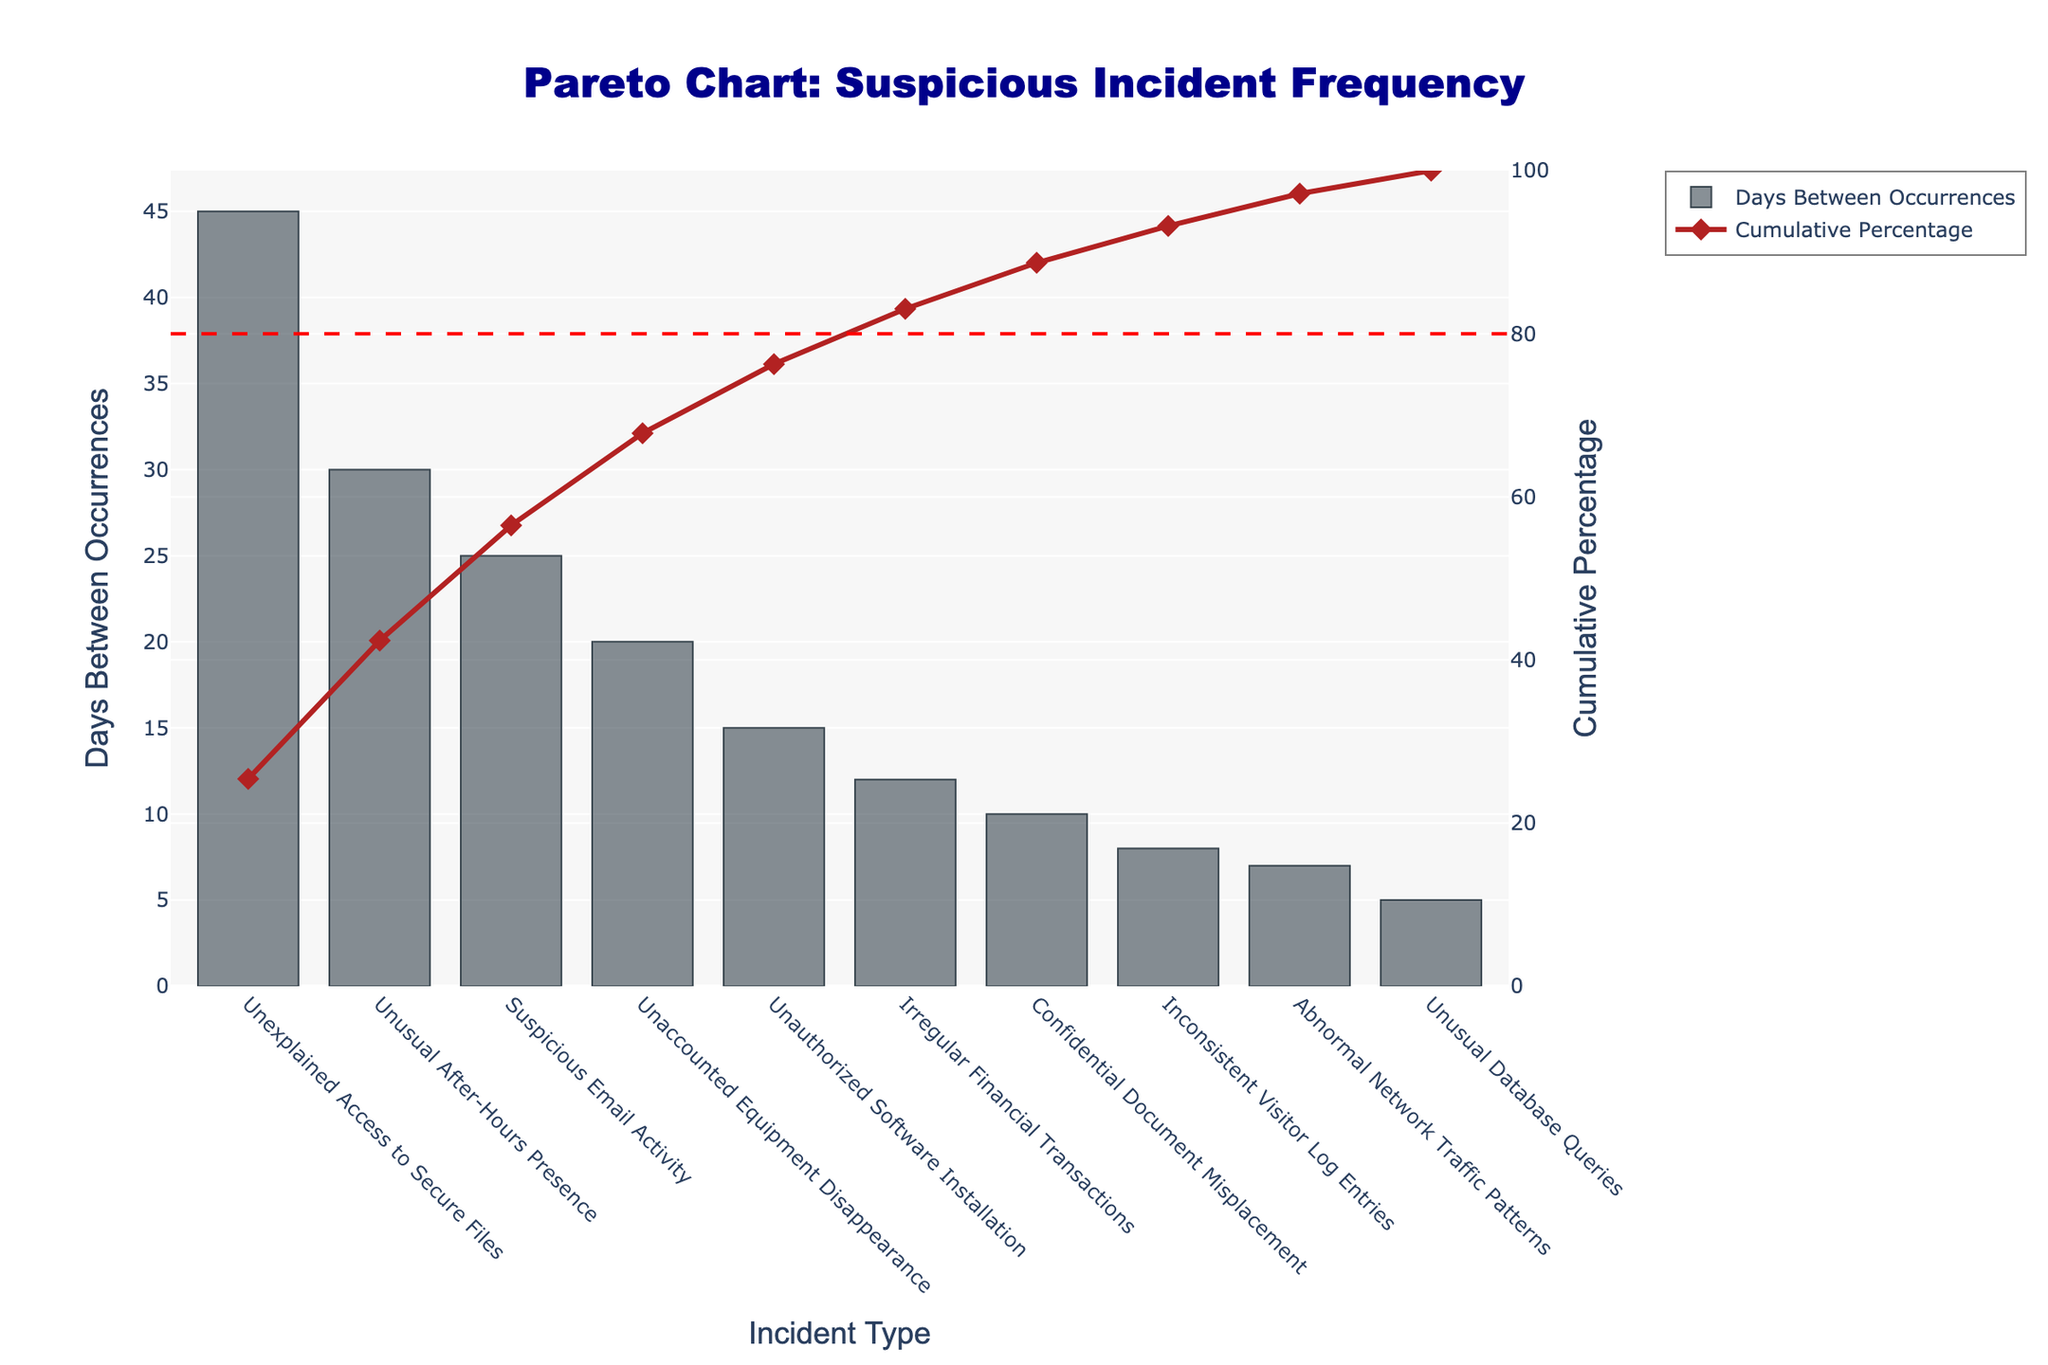What's the title of the chart? The title of the chart is prominently displayed at the top. From the given decorations and position, we can see that it reads "Pareto Chart: Suspicious Incident Frequency."
Answer: Pareto Chart: Suspicious Incident Frequency How many incident types are there in the chart? The chart displays the incident types horizontally along the x-axis. Counting each unique label, we find there are a total of 10 different incident types.
Answer: 10 Which incident type has the longest interval between occurrences? By observing the height of the bars, the "Unexplained Access to Secure Files" bar is the tallest, indicating it has the longest interval between occurrences.
Answer: Unexplained Access to Secure Files What is the cumulative percentage after "Suspicious Email Activity"? We identify the position of "Suspicious Email Activity" on the x-axis and follow the plot from the red line in the right y-axis (Cumulative Percentage). Looking at the point where it aligns, we see the cumulative percentage value.
Answer: Around 53% What is the total interval time between occurrences for the top three incident types? The top three incident types by bar height are "Unexplained Access to Secure Files," "Unusual After-Hours Presence," and "Suspicious Email Activity." Adding their intervals: 45 + 30 + 25 = 100 days.
Answer: 100 days Which incident type marks the 80% cumulative percentage? The red cumulative percentage line which is marked by the secondary y-axis crosses the 80% line. By tracing back down to the x-axis, we can see that "Irregular Financial Transactions" marks the 80% cumulative percentage.
Answer: Irregular Financial Transactions How much shorter is the interval for "Unusual Database Queries" compared to "Confidential Document Misplacement"? The interval for "Unusual Database Queries" is 5 days, and for "Confidential Document Misplacement," it is 10 days. The difference in interval time is 10 - 5 = 5 days.
Answer: 5 days Which incident type has the shortest interval between occurrences? By looking for the shortest bar, which represents the shortest time interval, we identify "Unusual Database Queries" as the incident type with the shortest interval of 5 days.
Answer: Unusual Database Queries What is the average interval between occurrences for all incident types? To find the average, sum the intervals for all incident types and divide by the number of incident types. The total interval is 45 + 30 + 25 + 20 + 15 + 12 + 10 + 8 + 7 + 5 = 177 days. There are 10 incident types: 177 / 10 = 17.7 days.
Answer: 17.7 days 